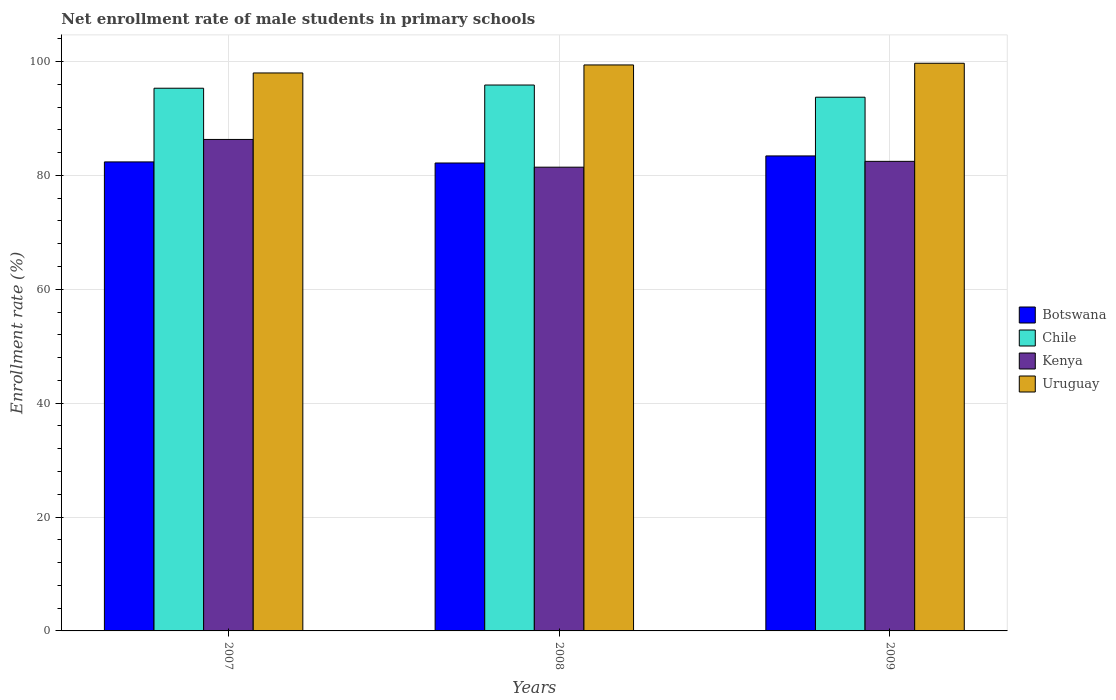How many different coloured bars are there?
Your answer should be compact. 4. How many groups of bars are there?
Give a very brief answer. 3. What is the label of the 2nd group of bars from the left?
Provide a succinct answer. 2008. What is the net enrollment rate of male students in primary schools in Botswana in 2009?
Ensure brevity in your answer.  83.42. Across all years, what is the maximum net enrollment rate of male students in primary schools in Kenya?
Give a very brief answer. 86.31. Across all years, what is the minimum net enrollment rate of male students in primary schools in Uruguay?
Your answer should be compact. 97.99. In which year was the net enrollment rate of male students in primary schools in Uruguay minimum?
Your answer should be compact. 2007. What is the total net enrollment rate of male students in primary schools in Botswana in the graph?
Make the answer very short. 247.96. What is the difference between the net enrollment rate of male students in primary schools in Botswana in 2008 and that in 2009?
Your answer should be very brief. -1.24. What is the difference between the net enrollment rate of male students in primary schools in Botswana in 2008 and the net enrollment rate of male students in primary schools in Uruguay in 2007?
Keep it short and to the point. -15.81. What is the average net enrollment rate of male students in primary schools in Kenya per year?
Ensure brevity in your answer.  83.41. In the year 2008, what is the difference between the net enrollment rate of male students in primary schools in Kenya and net enrollment rate of male students in primary schools in Botswana?
Provide a succinct answer. -0.74. In how many years, is the net enrollment rate of male students in primary schools in Botswana greater than 100 %?
Your response must be concise. 0. What is the ratio of the net enrollment rate of male students in primary schools in Chile in 2007 to that in 2009?
Your answer should be compact. 1.02. What is the difference between the highest and the second highest net enrollment rate of male students in primary schools in Uruguay?
Your response must be concise. 0.3. What is the difference between the highest and the lowest net enrollment rate of male students in primary schools in Kenya?
Your answer should be compact. 4.87. In how many years, is the net enrollment rate of male students in primary schools in Botswana greater than the average net enrollment rate of male students in primary schools in Botswana taken over all years?
Your answer should be very brief. 1. What does the 4th bar from the right in 2008 represents?
Make the answer very short. Botswana. Is it the case that in every year, the sum of the net enrollment rate of male students in primary schools in Uruguay and net enrollment rate of male students in primary schools in Chile is greater than the net enrollment rate of male students in primary schools in Botswana?
Offer a terse response. Yes. Are all the bars in the graph horizontal?
Your response must be concise. No. What is the difference between two consecutive major ticks on the Y-axis?
Your answer should be compact. 20. Are the values on the major ticks of Y-axis written in scientific E-notation?
Keep it short and to the point. No. How are the legend labels stacked?
Your answer should be compact. Vertical. What is the title of the graph?
Your response must be concise. Net enrollment rate of male students in primary schools. What is the label or title of the X-axis?
Ensure brevity in your answer.  Years. What is the label or title of the Y-axis?
Ensure brevity in your answer.  Enrollment rate (%). What is the Enrollment rate (%) of Botswana in 2007?
Your answer should be compact. 82.37. What is the Enrollment rate (%) of Chile in 2007?
Your answer should be very brief. 95.31. What is the Enrollment rate (%) in Kenya in 2007?
Your answer should be compact. 86.31. What is the Enrollment rate (%) of Uruguay in 2007?
Give a very brief answer. 97.99. What is the Enrollment rate (%) in Botswana in 2008?
Ensure brevity in your answer.  82.18. What is the Enrollment rate (%) of Chile in 2008?
Provide a short and direct response. 95.87. What is the Enrollment rate (%) in Kenya in 2008?
Keep it short and to the point. 81.44. What is the Enrollment rate (%) in Uruguay in 2008?
Your response must be concise. 99.4. What is the Enrollment rate (%) in Botswana in 2009?
Your answer should be very brief. 83.42. What is the Enrollment rate (%) in Chile in 2009?
Provide a short and direct response. 93.73. What is the Enrollment rate (%) of Kenya in 2009?
Ensure brevity in your answer.  82.46. What is the Enrollment rate (%) in Uruguay in 2009?
Ensure brevity in your answer.  99.69. Across all years, what is the maximum Enrollment rate (%) in Botswana?
Offer a very short reply. 83.42. Across all years, what is the maximum Enrollment rate (%) of Chile?
Provide a short and direct response. 95.87. Across all years, what is the maximum Enrollment rate (%) in Kenya?
Provide a succinct answer. 86.31. Across all years, what is the maximum Enrollment rate (%) in Uruguay?
Offer a very short reply. 99.69. Across all years, what is the minimum Enrollment rate (%) of Botswana?
Ensure brevity in your answer.  82.18. Across all years, what is the minimum Enrollment rate (%) in Chile?
Provide a succinct answer. 93.73. Across all years, what is the minimum Enrollment rate (%) in Kenya?
Your answer should be compact. 81.44. Across all years, what is the minimum Enrollment rate (%) in Uruguay?
Your answer should be very brief. 97.99. What is the total Enrollment rate (%) of Botswana in the graph?
Provide a short and direct response. 247.96. What is the total Enrollment rate (%) in Chile in the graph?
Offer a very short reply. 284.9. What is the total Enrollment rate (%) in Kenya in the graph?
Provide a short and direct response. 250.22. What is the total Enrollment rate (%) in Uruguay in the graph?
Your answer should be very brief. 297.08. What is the difference between the Enrollment rate (%) of Botswana in 2007 and that in 2008?
Make the answer very short. 0.19. What is the difference between the Enrollment rate (%) in Chile in 2007 and that in 2008?
Make the answer very short. -0.56. What is the difference between the Enrollment rate (%) of Kenya in 2007 and that in 2008?
Offer a very short reply. 4.87. What is the difference between the Enrollment rate (%) of Uruguay in 2007 and that in 2008?
Keep it short and to the point. -1.41. What is the difference between the Enrollment rate (%) of Botswana in 2007 and that in 2009?
Offer a very short reply. -1.05. What is the difference between the Enrollment rate (%) of Chile in 2007 and that in 2009?
Give a very brief answer. 1.58. What is the difference between the Enrollment rate (%) of Kenya in 2007 and that in 2009?
Provide a short and direct response. 3.85. What is the difference between the Enrollment rate (%) in Uruguay in 2007 and that in 2009?
Keep it short and to the point. -1.7. What is the difference between the Enrollment rate (%) of Botswana in 2008 and that in 2009?
Make the answer very short. -1.24. What is the difference between the Enrollment rate (%) in Chile in 2008 and that in 2009?
Provide a short and direct response. 2.14. What is the difference between the Enrollment rate (%) in Kenya in 2008 and that in 2009?
Offer a terse response. -1.02. What is the difference between the Enrollment rate (%) of Uruguay in 2008 and that in 2009?
Offer a very short reply. -0.3. What is the difference between the Enrollment rate (%) of Botswana in 2007 and the Enrollment rate (%) of Chile in 2008?
Keep it short and to the point. -13.5. What is the difference between the Enrollment rate (%) in Botswana in 2007 and the Enrollment rate (%) in Kenya in 2008?
Offer a terse response. 0.93. What is the difference between the Enrollment rate (%) in Botswana in 2007 and the Enrollment rate (%) in Uruguay in 2008?
Offer a terse response. -17.03. What is the difference between the Enrollment rate (%) of Chile in 2007 and the Enrollment rate (%) of Kenya in 2008?
Offer a very short reply. 13.87. What is the difference between the Enrollment rate (%) in Chile in 2007 and the Enrollment rate (%) in Uruguay in 2008?
Make the answer very short. -4.09. What is the difference between the Enrollment rate (%) of Kenya in 2007 and the Enrollment rate (%) of Uruguay in 2008?
Offer a terse response. -13.08. What is the difference between the Enrollment rate (%) of Botswana in 2007 and the Enrollment rate (%) of Chile in 2009?
Give a very brief answer. -11.36. What is the difference between the Enrollment rate (%) of Botswana in 2007 and the Enrollment rate (%) of Kenya in 2009?
Your answer should be very brief. -0.1. What is the difference between the Enrollment rate (%) in Botswana in 2007 and the Enrollment rate (%) in Uruguay in 2009?
Offer a terse response. -17.32. What is the difference between the Enrollment rate (%) in Chile in 2007 and the Enrollment rate (%) in Kenya in 2009?
Keep it short and to the point. 12.84. What is the difference between the Enrollment rate (%) of Chile in 2007 and the Enrollment rate (%) of Uruguay in 2009?
Your answer should be very brief. -4.39. What is the difference between the Enrollment rate (%) of Kenya in 2007 and the Enrollment rate (%) of Uruguay in 2009?
Give a very brief answer. -13.38. What is the difference between the Enrollment rate (%) in Botswana in 2008 and the Enrollment rate (%) in Chile in 2009?
Offer a terse response. -11.55. What is the difference between the Enrollment rate (%) in Botswana in 2008 and the Enrollment rate (%) in Kenya in 2009?
Offer a terse response. -0.29. What is the difference between the Enrollment rate (%) in Botswana in 2008 and the Enrollment rate (%) in Uruguay in 2009?
Offer a very short reply. -17.52. What is the difference between the Enrollment rate (%) of Chile in 2008 and the Enrollment rate (%) of Kenya in 2009?
Your answer should be compact. 13.4. What is the difference between the Enrollment rate (%) of Chile in 2008 and the Enrollment rate (%) of Uruguay in 2009?
Provide a short and direct response. -3.82. What is the difference between the Enrollment rate (%) in Kenya in 2008 and the Enrollment rate (%) in Uruguay in 2009?
Provide a succinct answer. -18.25. What is the average Enrollment rate (%) in Botswana per year?
Ensure brevity in your answer.  82.65. What is the average Enrollment rate (%) of Chile per year?
Offer a terse response. 94.97. What is the average Enrollment rate (%) of Kenya per year?
Provide a succinct answer. 83.41. What is the average Enrollment rate (%) of Uruguay per year?
Make the answer very short. 99.03. In the year 2007, what is the difference between the Enrollment rate (%) in Botswana and Enrollment rate (%) in Chile?
Your response must be concise. -12.94. In the year 2007, what is the difference between the Enrollment rate (%) in Botswana and Enrollment rate (%) in Kenya?
Your answer should be compact. -3.95. In the year 2007, what is the difference between the Enrollment rate (%) in Botswana and Enrollment rate (%) in Uruguay?
Provide a short and direct response. -15.62. In the year 2007, what is the difference between the Enrollment rate (%) of Chile and Enrollment rate (%) of Kenya?
Offer a very short reply. 8.99. In the year 2007, what is the difference between the Enrollment rate (%) of Chile and Enrollment rate (%) of Uruguay?
Your answer should be very brief. -2.68. In the year 2007, what is the difference between the Enrollment rate (%) in Kenya and Enrollment rate (%) in Uruguay?
Your answer should be compact. -11.68. In the year 2008, what is the difference between the Enrollment rate (%) in Botswana and Enrollment rate (%) in Chile?
Your answer should be compact. -13.69. In the year 2008, what is the difference between the Enrollment rate (%) in Botswana and Enrollment rate (%) in Kenya?
Your answer should be compact. 0.74. In the year 2008, what is the difference between the Enrollment rate (%) of Botswana and Enrollment rate (%) of Uruguay?
Provide a short and direct response. -17.22. In the year 2008, what is the difference between the Enrollment rate (%) in Chile and Enrollment rate (%) in Kenya?
Your response must be concise. 14.43. In the year 2008, what is the difference between the Enrollment rate (%) in Chile and Enrollment rate (%) in Uruguay?
Your answer should be compact. -3.53. In the year 2008, what is the difference between the Enrollment rate (%) of Kenya and Enrollment rate (%) of Uruguay?
Provide a succinct answer. -17.96. In the year 2009, what is the difference between the Enrollment rate (%) in Botswana and Enrollment rate (%) in Chile?
Keep it short and to the point. -10.31. In the year 2009, what is the difference between the Enrollment rate (%) of Botswana and Enrollment rate (%) of Kenya?
Provide a short and direct response. 0.95. In the year 2009, what is the difference between the Enrollment rate (%) in Botswana and Enrollment rate (%) in Uruguay?
Your answer should be compact. -16.28. In the year 2009, what is the difference between the Enrollment rate (%) in Chile and Enrollment rate (%) in Kenya?
Provide a short and direct response. 11.27. In the year 2009, what is the difference between the Enrollment rate (%) of Chile and Enrollment rate (%) of Uruguay?
Keep it short and to the point. -5.96. In the year 2009, what is the difference between the Enrollment rate (%) of Kenya and Enrollment rate (%) of Uruguay?
Offer a very short reply. -17.23. What is the ratio of the Enrollment rate (%) of Kenya in 2007 to that in 2008?
Provide a short and direct response. 1.06. What is the ratio of the Enrollment rate (%) in Uruguay in 2007 to that in 2008?
Give a very brief answer. 0.99. What is the ratio of the Enrollment rate (%) in Botswana in 2007 to that in 2009?
Make the answer very short. 0.99. What is the ratio of the Enrollment rate (%) in Chile in 2007 to that in 2009?
Provide a succinct answer. 1.02. What is the ratio of the Enrollment rate (%) of Kenya in 2007 to that in 2009?
Provide a succinct answer. 1.05. What is the ratio of the Enrollment rate (%) in Uruguay in 2007 to that in 2009?
Your response must be concise. 0.98. What is the ratio of the Enrollment rate (%) of Botswana in 2008 to that in 2009?
Your answer should be very brief. 0.99. What is the ratio of the Enrollment rate (%) of Chile in 2008 to that in 2009?
Keep it short and to the point. 1.02. What is the ratio of the Enrollment rate (%) in Kenya in 2008 to that in 2009?
Offer a very short reply. 0.99. What is the ratio of the Enrollment rate (%) in Uruguay in 2008 to that in 2009?
Offer a very short reply. 1. What is the difference between the highest and the second highest Enrollment rate (%) of Botswana?
Offer a very short reply. 1.05. What is the difference between the highest and the second highest Enrollment rate (%) in Chile?
Keep it short and to the point. 0.56. What is the difference between the highest and the second highest Enrollment rate (%) of Kenya?
Offer a very short reply. 3.85. What is the difference between the highest and the second highest Enrollment rate (%) in Uruguay?
Make the answer very short. 0.3. What is the difference between the highest and the lowest Enrollment rate (%) in Botswana?
Give a very brief answer. 1.24. What is the difference between the highest and the lowest Enrollment rate (%) in Chile?
Ensure brevity in your answer.  2.14. What is the difference between the highest and the lowest Enrollment rate (%) in Kenya?
Make the answer very short. 4.87. What is the difference between the highest and the lowest Enrollment rate (%) of Uruguay?
Offer a very short reply. 1.7. 